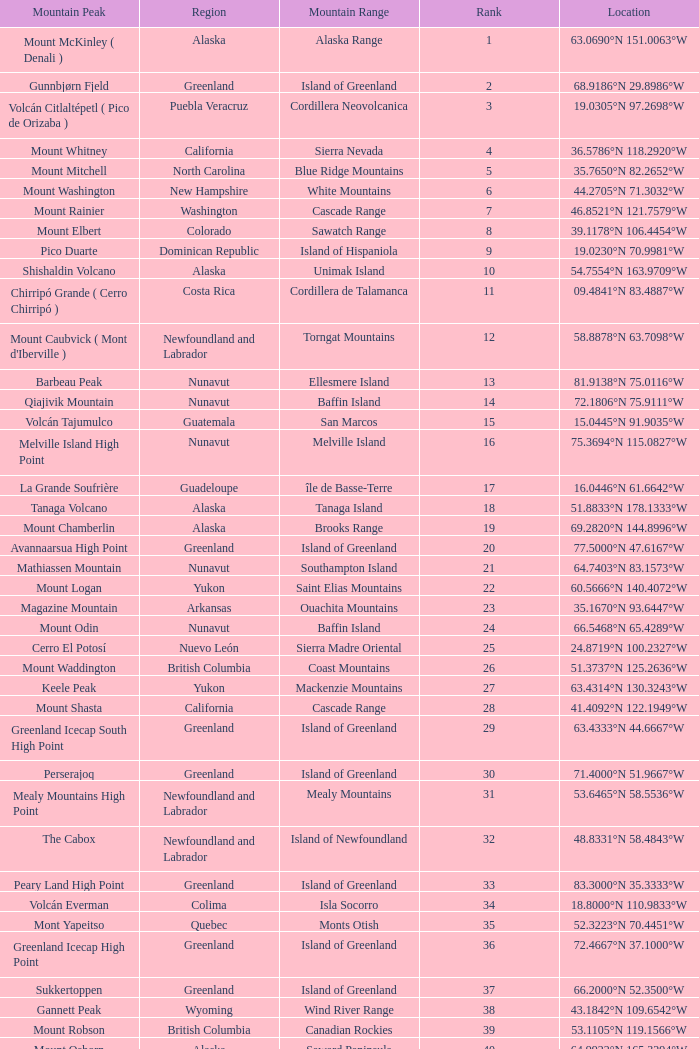Which Mountain Peak has a Region of baja california, and a Location of 28.1301°n 115.2206°w? Isla Cedros High Point. 